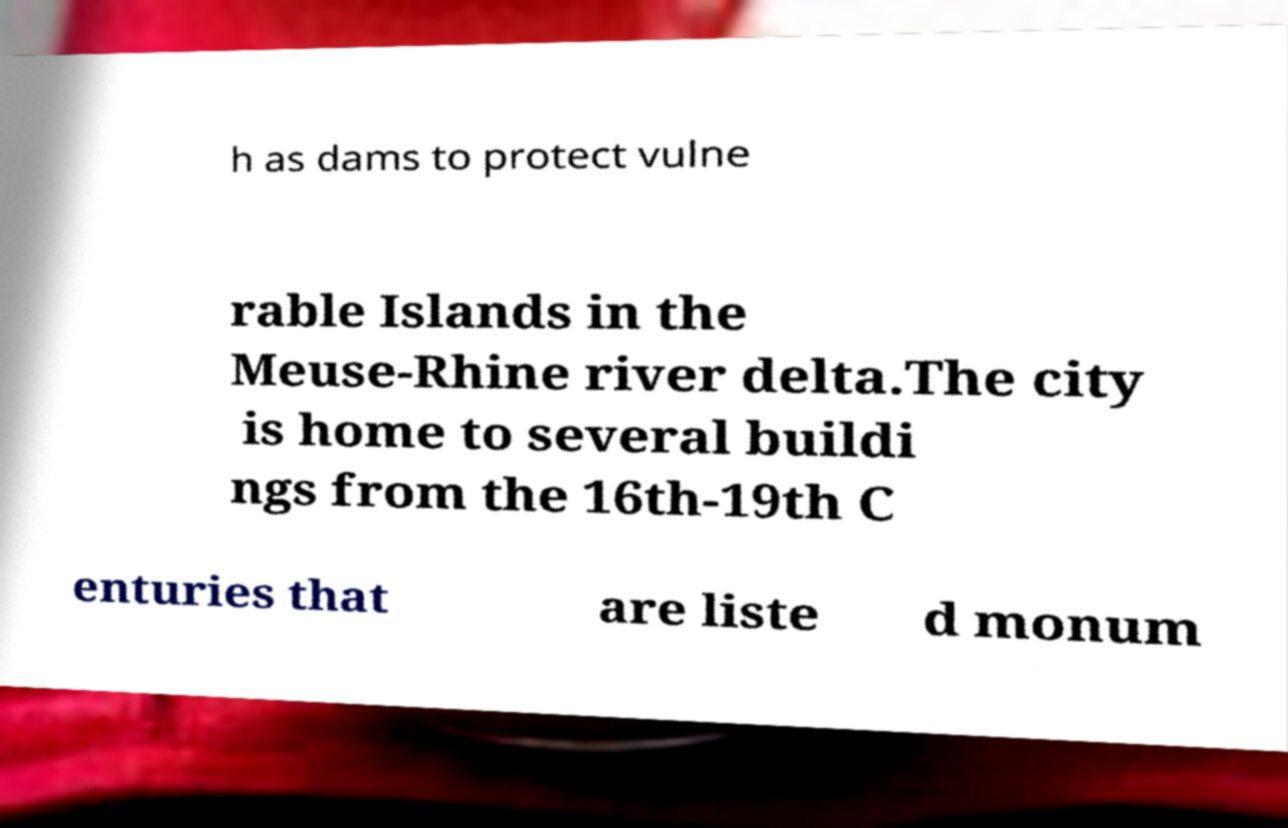Can you accurately transcribe the text from the provided image for me? h as dams to protect vulne rable Islands in the Meuse-Rhine river delta.The city is home to several buildi ngs from the 16th-19th C enturies that are liste d monum 